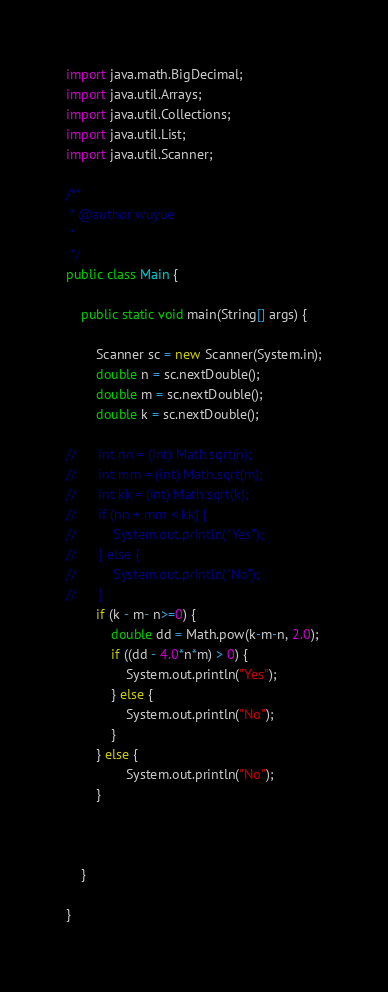<code> <loc_0><loc_0><loc_500><loc_500><_Java_>import java.math.BigDecimal;
import java.util.Arrays;
import java.util.Collections;
import java.util.List;
import java.util.Scanner;

/**
 * @author wuyue
 *
 */
public class Main {

	public static void main(String[] args) {

		Scanner sc = new Scanner(System.in);
		double n = sc.nextDouble();
		double m = sc.nextDouble();
		double k = sc.nextDouble();
		
//		int nn = (int) Math.sqrt(n);
//		int mm = (int) Math.sqrt(m);
//		int kk = (int) Math.sqrt(k);
//		if (nn + mm < kk) {
//			System.out.println("Yes");
//		} else {
//			System.out.println("No");
//		}
		if (k - m- n>=0) {
			double dd = Math.pow(k-m-n, 2.0);
			if ((dd - 4.0*n*m) > 0) {
				System.out.println("Yes");
			} else {
				System.out.println("No");
			}
		} else {
				System.out.println("No");
		}
		
		
		
	}

}
</code> 